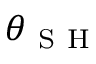<formula> <loc_0><loc_0><loc_500><loc_500>\theta _ { S H }</formula> 